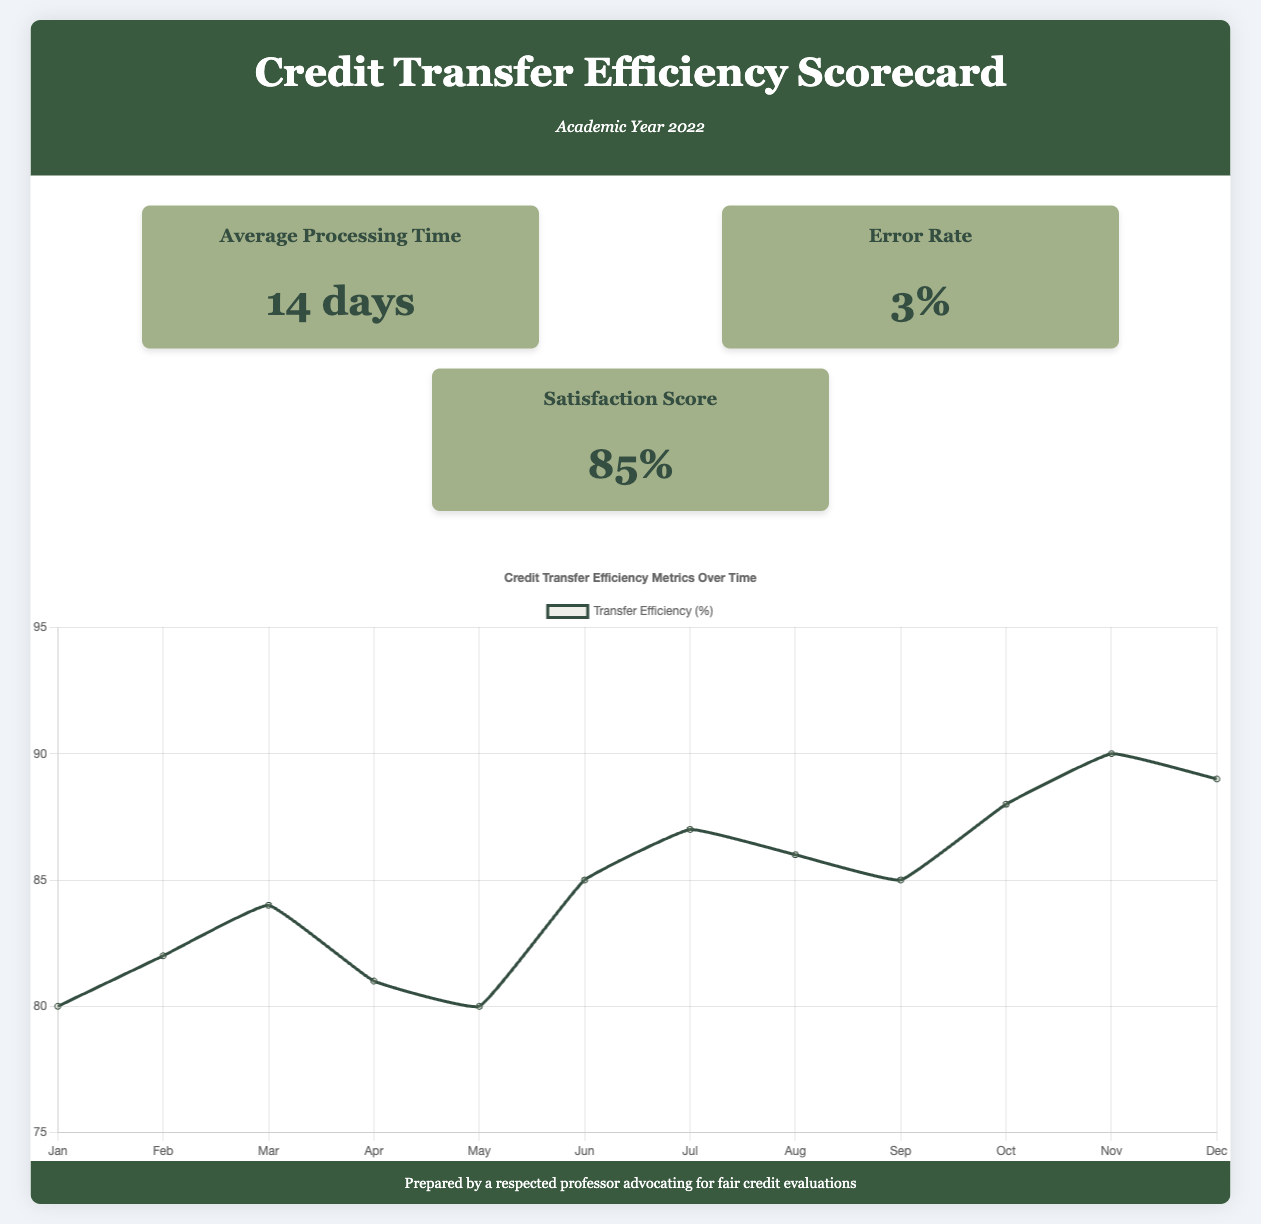What is the average processing time for credit transfers? The average processing time is displayed in the metric section, which states it is 14 days.
Answer: 14 days What is the error rate in credit transfers? The error rate is mentioned in the metric section as 3%.
Answer: 3% What is the satisfaction score for student experiences with credit transfers? The satisfaction score is provided in the scorecard, which indicates it is 85%.
Answer: 85% What was the highest transfer efficiency percentage during 2022? The highest transfer efficiency percentage can be observed from the chart data for December, which is 90%.
Answer: 90% What month did the transfer efficiency first exceed 85%? The chart shows that transfer efficiency first exceeded 85% in July, corresponding to the value of 87%.
Answer: July What color is associated with the transfer efficiency line in the chart? The chart specifies that the line representing transfer efficiency has a border color of dark green.
Answer: Dark green What is the title of the scorecard? The title of the scorecard is clearly labeled at the top of the document.
Answer: Credit Transfer Efficiency Scorecard What year does the scorecard focus on? The subtitle under the title explicitly mentions the academic year the scorecard reflects.
Answer: 2022 How many months are represented on the x-axis of the chart? The chart displays data across a full year's timeline, indicating a total of 12 months on the x-axis.
Answer: 12 months 